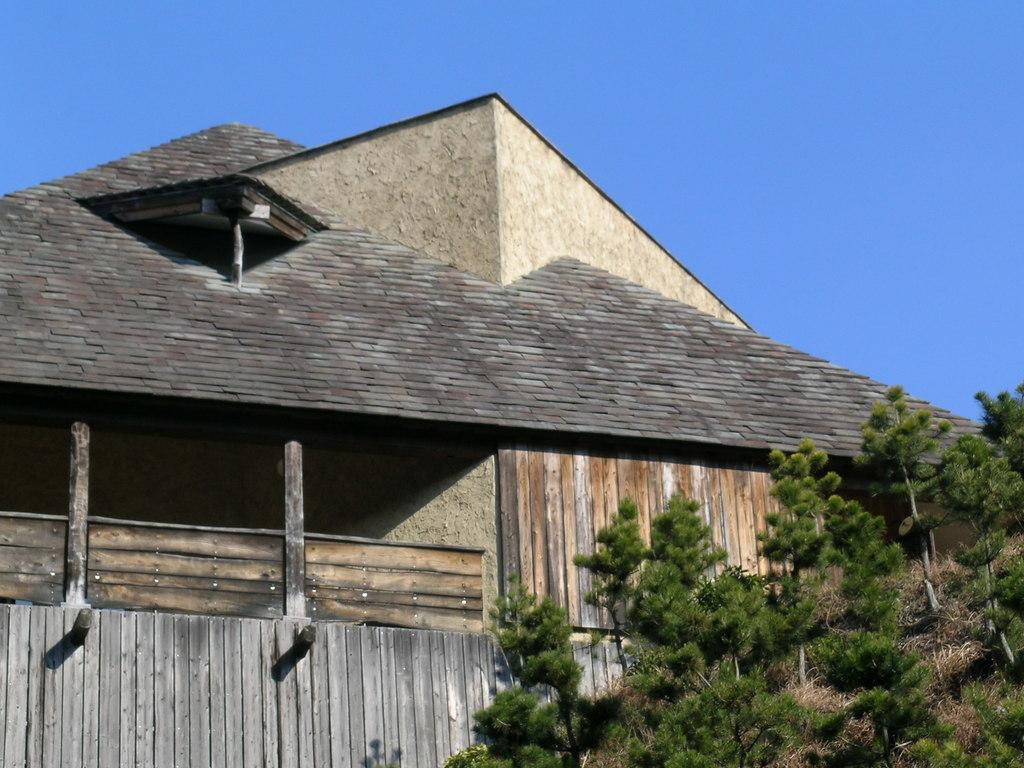What type of structure is present in the image? There is a building in the image. What other natural elements can be seen in the image? There are trees in the image. What is visible in the background of the image? The sky is visible in the image. What type of bun is being used to stop the apple from rolling away in the image? There is no bun or apple present in the image, so this question cannot be answered. 